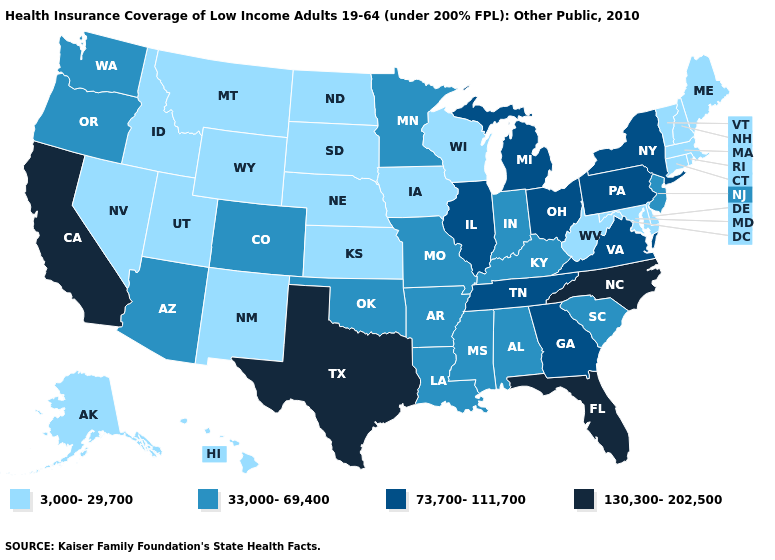What is the highest value in states that border Wyoming?
Write a very short answer. 33,000-69,400. What is the value of Kentucky?
Keep it brief. 33,000-69,400. Does Michigan have a higher value than Georgia?
Short answer required. No. What is the value of Arizona?
Concise answer only. 33,000-69,400. What is the highest value in states that border Pennsylvania?
Answer briefly. 73,700-111,700. Does Minnesota have a lower value than Utah?
Write a very short answer. No. What is the value of New Mexico?
Keep it brief. 3,000-29,700. Name the states that have a value in the range 3,000-29,700?
Keep it brief. Alaska, Connecticut, Delaware, Hawaii, Idaho, Iowa, Kansas, Maine, Maryland, Massachusetts, Montana, Nebraska, Nevada, New Hampshire, New Mexico, North Dakota, Rhode Island, South Dakota, Utah, Vermont, West Virginia, Wisconsin, Wyoming. Does Tennessee have a lower value than Florida?
Answer briefly. Yes. Among the states that border Nebraska , does Wyoming have the highest value?
Give a very brief answer. No. What is the highest value in the West ?
Give a very brief answer. 130,300-202,500. Does Tennessee have the highest value in the USA?
Write a very short answer. No. What is the value of New Jersey?
Write a very short answer. 33,000-69,400. Does Connecticut have the highest value in the Northeast?
Give a very brief answer. No. 